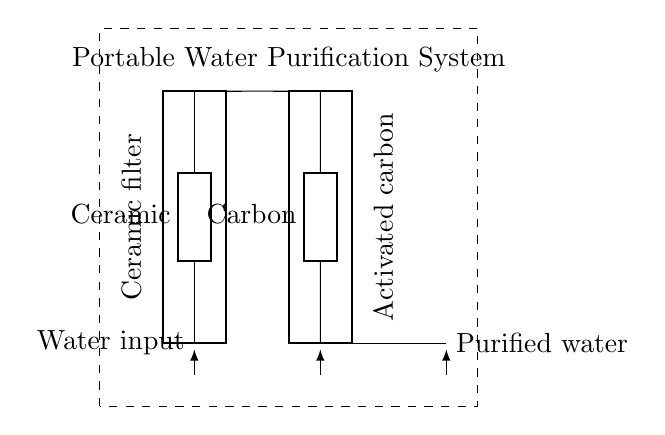What are the two main components in this system? The two main components are the ceramic filter and the activated carbon filter, which are visually represented as distinct blocks in the circuit diagram.
Answer: Ceramic filter and activated carbon filter What is the purpose of the ceramic filter? The ceramic filter is used to remove larger particles and contaminants from the water, serving as the primary filtration step in the purification process as indicated by its position at the input.
Answer: Remove larger particles What does the dashed rectangle represent? The dashed rectangle encloses the entire system, indicating that all components within it function together as a unified portable water purification system.
Answer: Portable water purification system Which direction does the water flow in the circuit? The arrows indicate the flow direction starting from the water input, going through the ceramic and activated carbon filters, and then exiting as purified water, showing a clear movement from input to output.
Answer: From input to output What is the final output of the system? The final output is clarified as purified water, which is noted at the end of the diagram after the filtration processes have occurred through both filters.
Answer: Purified water Why is activated carbon used after the ceramic filter? Activated carbon is utilized after the ceramic filter to further filter out smaller contaminants and chemicals from the water, enhancing the purification process after larger particles are removed by the ceramic filter.
Answer: To remove smaller contaminants 